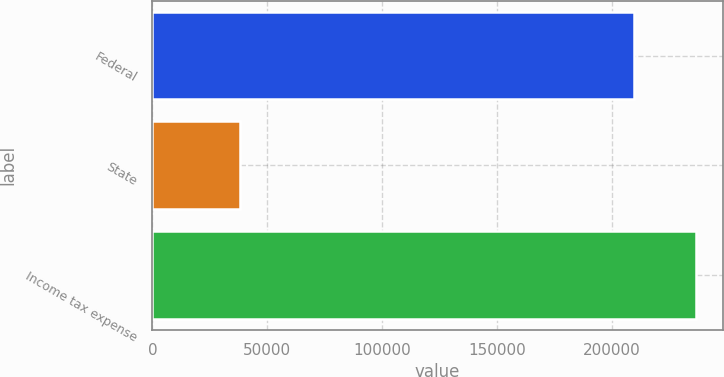<chart> <loc_0><loc_0><loc_500><loc_500><bar_chart><fcel>Federal<fcel>State<fcel>Income tax expense<nl><fcel>209454<fcel>38095<fcel>236435<nl></chart> 